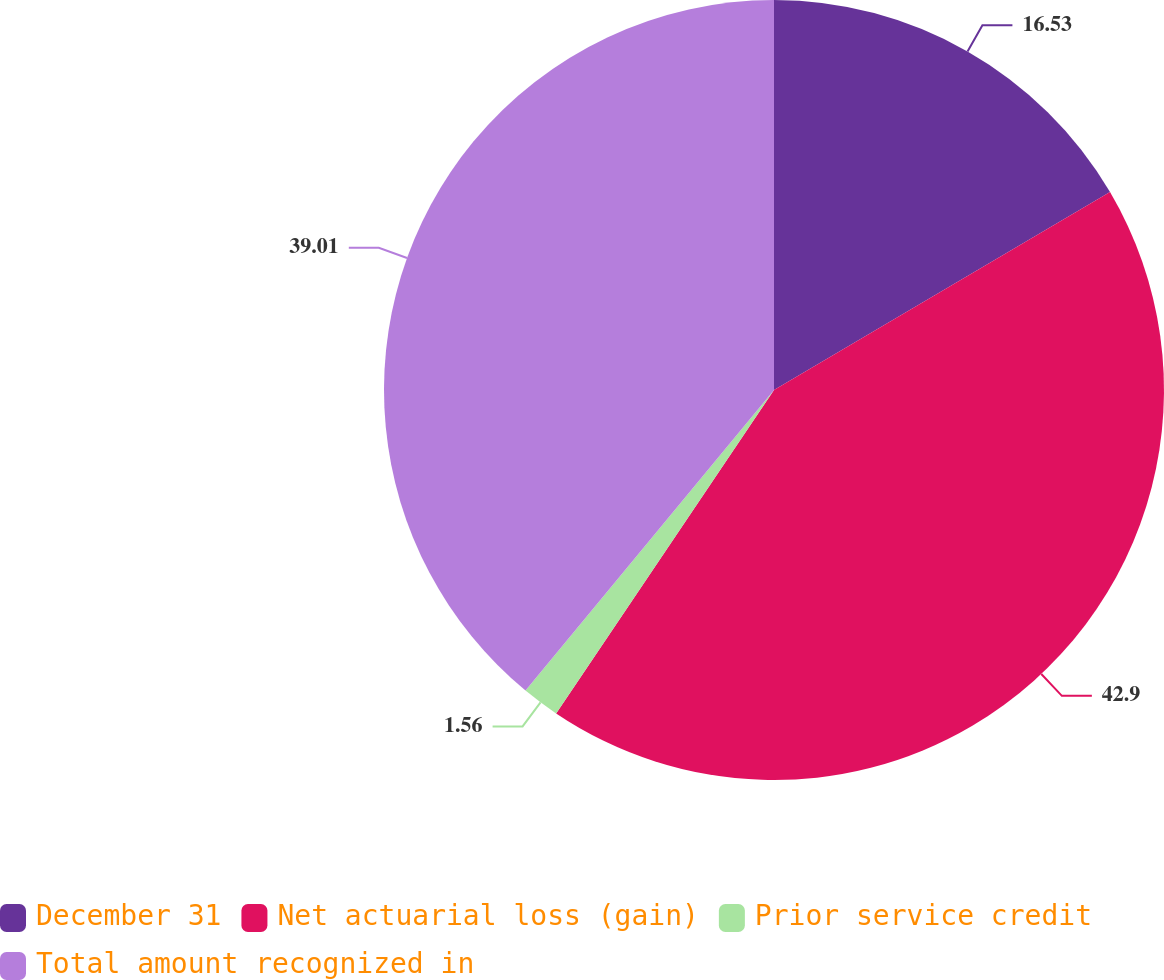<chart> <loc_0><loc_0><loc_500><loc_500><pie_chart><fcel>December 31<fcel>Net actuarial loss (gain)<fcel>Prior service credit<fcel>Total amount recognized in<nl><fcel>16.53%<fcel>42.91%<fcel>1.56%<fcel>39.01%<nl></chart> 